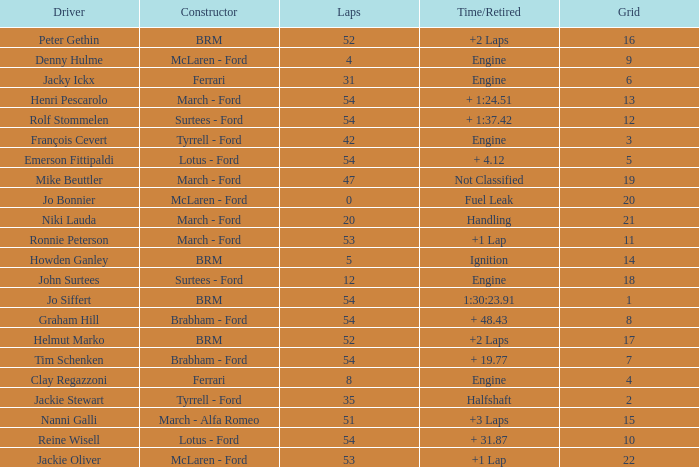Help me parse the entirety of this table. {'header': ['Driver', 'Constructor', 'Laps', 'Time/Retired', 'Grid'], 'rows': [['Peter Gethin', 'BRM', '52', '+2 Laps', '16'], ['Denny Hulme', 'McLaren - Ford', '4', 'Engine', '9'], ['Jacky Ickx', 'Ferrari', '31', 'Engine', '6'], ['Henri Pescarolo', 'March - Ford', '54', '+ 1:24.51', '13'], ['Rolf Stommelen', 'Surtees - Ford', '54', '+ 1:37.42', '12'], ['François Cevert', 'Tyrrell - Ford', '42', 'Engine', '3'], ['Emerson Fittipaldi', 'Lotus - Ford', '54', '+ 4.12', '5'], ['Mike Beuttler', 'March - Ford', '47', 'Not Classified', '19'], ['Jo Bonnier', 'McLaren - Ford', '0', 'Fuel Leak', '20'], ['Niki Lauda', 'March - Ford', '20', 'Handling', '21'], ['Ronnie Peterson', 'March - Ford', '53', '+1 Lap', '11'], ['Howden Ganley', 'BRM', '5', 'Ignition', '14'], ['John Surtees', 'Surtees - Ford', '12', 'Engine', '18'], ['Jo Siffert', 'BRM', '54', '1:30:23.91', '1'], ['Graham Hill', 'Brabham - Ford', '54', '+ 48.43', '8'], ['Helmut Marko', 'BRM', '52', '+2 Laps', '17'], ['Tim Schenken', 'Brabham - Ford', '54', '+ 19.77', '7'], ['Clay Regazzoni', 'Ferrari', '8', 'Engine', '4'], ['Jackie Stewart', 'Tyrrell - Ford', '35', 'Halfshaft', '2'], ['Nanni Galli', 'March - Alfa Romeo', '51', '+3 Laps', '15'], ['Reine Wisell', 'Lotus - Ford', '54', '+ 31.87', '10'], ['Jackie Oliver', 'McLaren - Ford', '53', '+1 Lap', '22']]} What is the low grid that has brm and over 54 laps? None. 